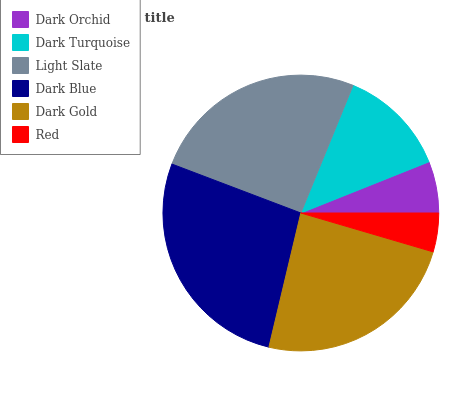Is Red the minimum?
Answer yes or no. Yes. Is Dark Blue the maximum?
Answer yes or no. Yes. Is Dark Turquoise the minimum?
Answer yes or no. No. Is Dark Turquoise the maximum?
Answer yes or no. No. Is Dark Turquoise greater than Dark Orchid?
Answer yes or no. Yes. Is Dark Orchid less than Dark Turquoise?
Answer yes or no. Yes. Is Dark Orchid greater than Dark Turquoise?
Answer yes or no. No. Is Dark Turquoise less than Dark Orchid?
Answer yes or no. No. Is Dark Gold the high median?
Answer yes or no. Yes. Is Dark Turquoise the low median?
Answer yes or no. Yes. Is Red the high median?
Answer yes or no. No. Is Dark Gold the low median?
Answer yes or no. No. 